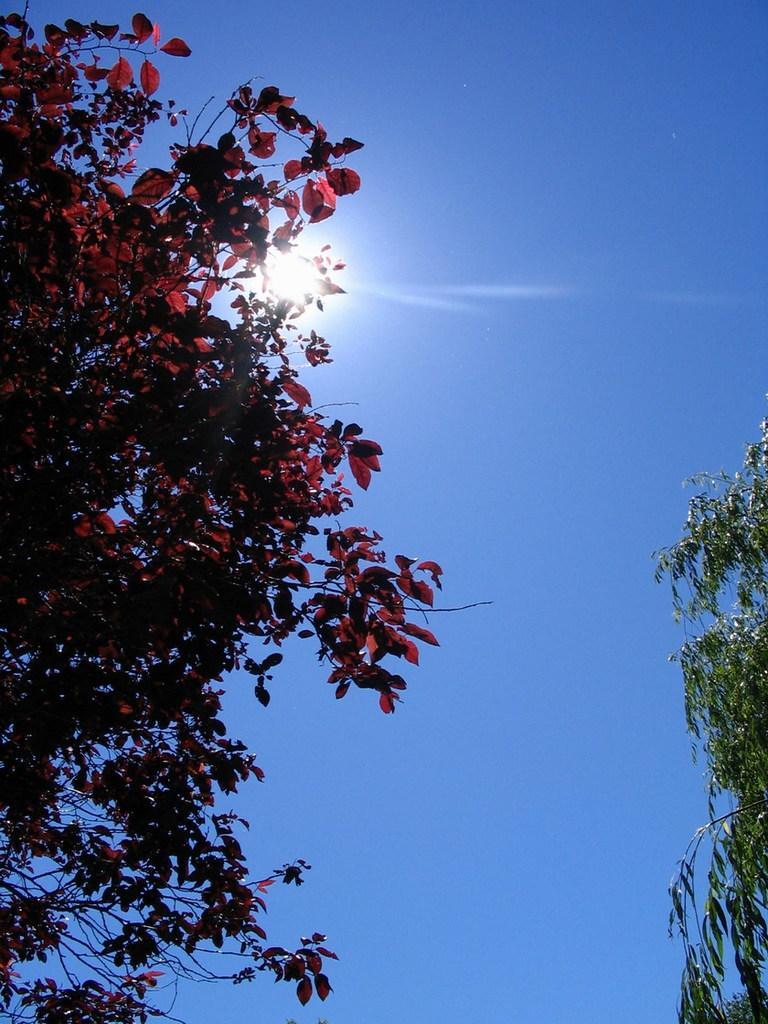In one or two sentences, can you explain what this image depicts? In the foreground of this picture, there is a tree with red leaves. On the right, there is an another tree. In the background, there is the sky and the sun. 